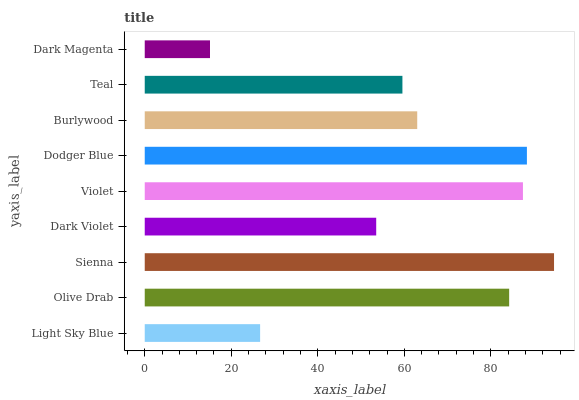Is Dark Magenta the minimum?
Answer yes or no. Yes. Is Sienna the maximum?
Answer yes or no. Yes. Is Olive Drab the minimum?
Answer yes or no. No. Is Olive Drab the maximum?
Answer yes or no. No. Is Olive Drab greater than Light Sky Blue?
Answer yes or no. Yes. Is Light Sky Blue less than Olive Drab?
Answer yes or no. Yes. Is Light Sky Blue greater than Olive Drab?
Answer yes or no. No. Is Olive Drab less than Light Sky Blue?
Answer yes or no. No. Is Burlywood the high median?
Answer yes or no. Yes. Is Burlywood the low median?
Answer yes or no. Yes. Is Light Sky Blue the high median?
Answer yes or no. No. Is Dark Magenta the low median?
Answer yes or no. No. 